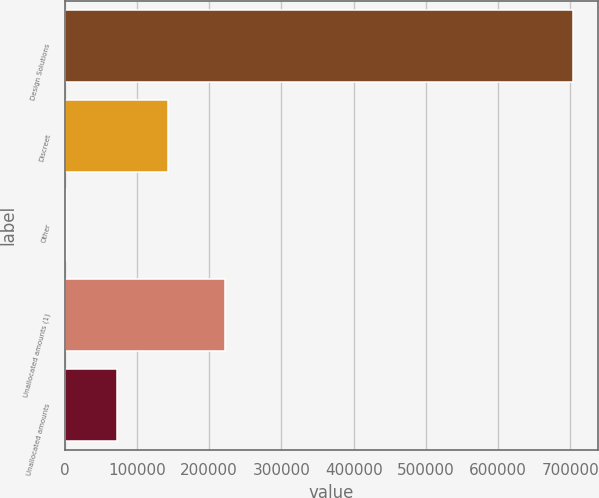Convert chart. <chart><loc_0><loc_0><loc_500><loc_500><bar_chart><fcel>Design Solutions<fcel>Discreet<fcel>Other<fcel>Unallocated amounts (1)<fcel>Unallocated amounts<nl><fcel>703529<fcel>142333<fcel>2034<fcel>221728<fcel>72183.5<nl></chart> 